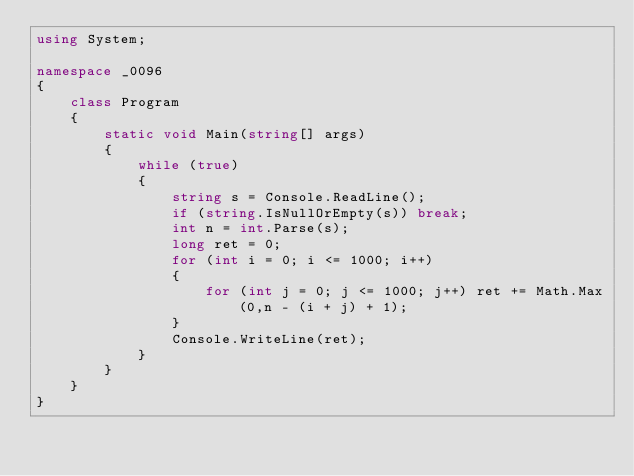<code> <loc_0><loc_0><loc_500><loc_500><_C#_>using System;

namespace _0096
{
    class Program
    {
        static void Main(string[] args)
        {
            while (true)
            {
                string s = Console.ReadLine();
                if (string.IsNullOrEmpty(s)) break;
                int n = int.Parse(s);
                long ret = 0;
                for (int i = 0; i <= 1000; i++)
                {
                    for (int j = 0; j <= 1000; j++) ret += Math.Max(0,n - (i + j) + 1);
                }
                Console.WriteLine(ret);
            }
        }
    }
}
</code> 